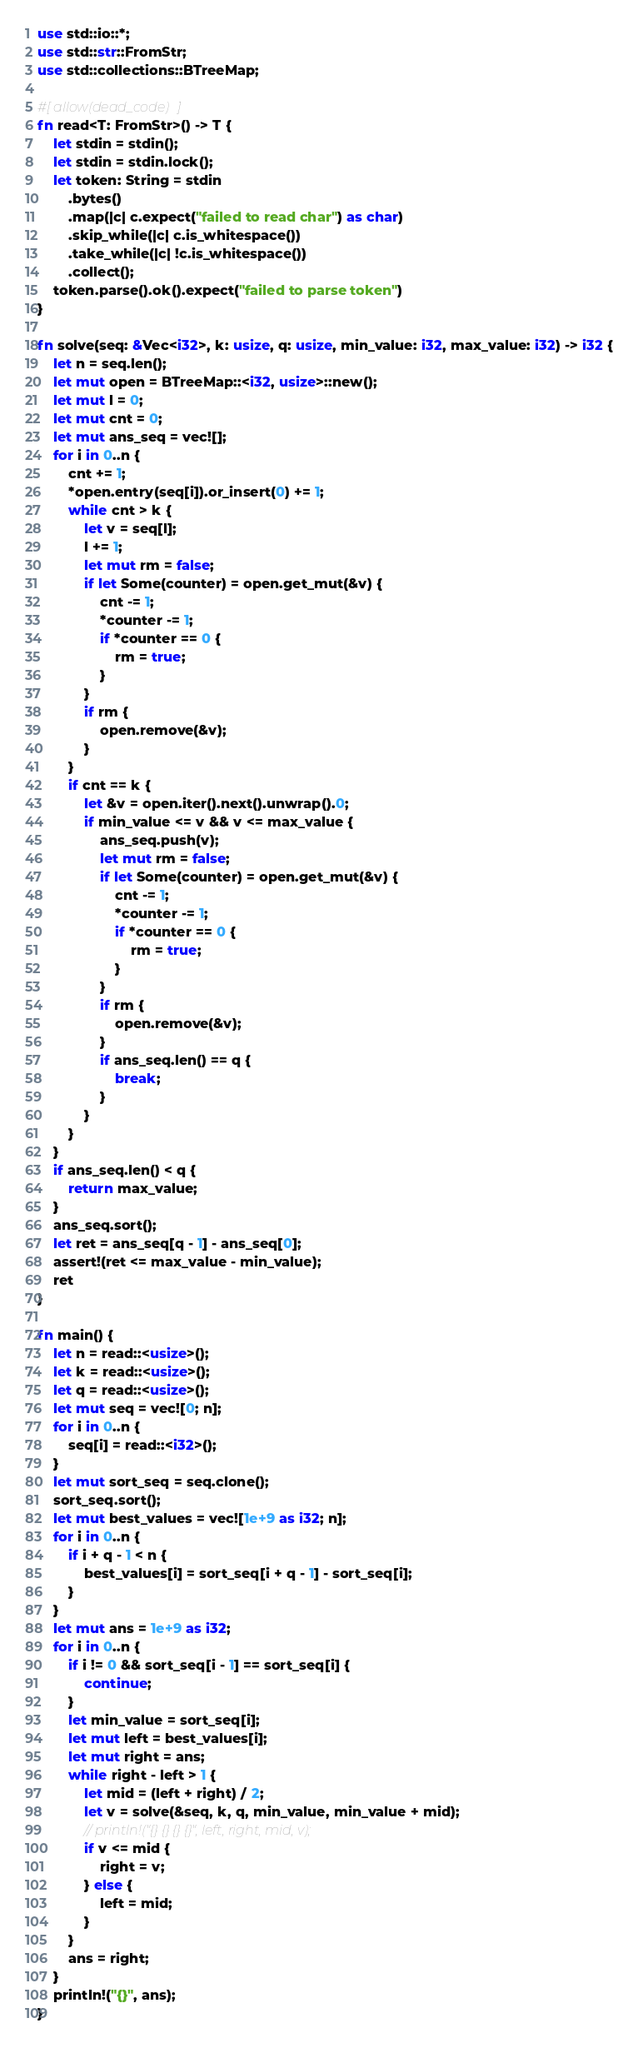<code> <loc_0><loc_0><loc_500><loc_500><_Rust_>use std::io::*;
use std::str::FromStr;
use std::collections::BTreeMap;

#[allow(dead_code)]
fn read<T: FromStr>() -> T {
    let stdin = stdin();
    let stdin = stdin.lock();
    let token: String = stdin
        .bytes()
        .map(|c| c.expect("failed to read char") as char)
        .skip_while(|c| c.is_whitespace())
        .take_while(|c| !c.is_whitespace())
        .collect();
    token.parse().ok().expect("failed to parse token")
}

fn solve(seq: &Vec<i32>, k: usize, q: usize, min_value: i32, max_value: i32) -> i32 {
    let n = seq.len();
    let mut open = BTreeMap::<i32, usize>::new();
    let mut l = 0;
    let mut cnt = 0;
    let mut ans_seq = vec![];
    for i in 0..n {
        cnt += 1;
        *open.entry(seq[i]).or_insert(0) += 1;
        while cnt > k {
            let v = seq[l];
            l += 1;
            let mut rm = false;
            if let Some(counter) = open.get_mut(&v) {
                cnt -= 1;
                *counter -= 1;
                if *counter == 0 {
                    rm = true;
                }
            }
            if rm {
                open.remove(&v);
            }
        }
        if cnt == k {
            let &v = open.iter().next().unwrap().0;
            if min_value <= v && v <= max_value {
                ans_seq.push(v);
                let mut rm = false;
                if let Some(counter) = open.get_mut(&v) {
                    cnt -= 1;
                    *counter -= 1;
                    if *counter == 0 {
                        rm = true;
                    }
                }
                if rm {
                    open.remove(&v);
                }
                if ans_seq.len() == q {
                    break;
                }
            }
        }
    }
    if ans_seq.len() < q {
        return max_value;
    }
    ans_seq.sort();
    let ret = ans_seq[q - 1] - ans_seq[0];
    assert!(ret <= max_value - min_value);
    ret
}

fn main() {
    let n = read::<usize>();
    let k = read::<usize>();
    let q = read::<usize>();
    let mut seq = vec![0; n];
    for i in 0..n {
        seq[i] = read::<i32>();
    }
    let mut sort_seq = seq.clone();
    sort_seq.sort();
    let mut best_values = vec![1e+9 as i32; n];
    for i in 0..n {
        if i + q - 1 < n {
            best_values[i] = sort_seq[i + q - 1] - sort_seq[i];
        }
    }
    let mut ans = 1e+9 as i32;
    for i in 0..n {
        if i != 0 && sort_seq[i - 1] == sort_seq[i] {
            continue;
        }
        let min_value = sort_seq[i];
        let mut left = best_values[i];
        let mut right = ans;
        while right - left > 1 {
            let mid = (left + right) / 2;
            let v = solve(&seq, k, q, min_value, min_value + mid);
            // println!("{} {} {} {}", left, right, mid, v);
            if v <= mid {
                right = v;
            } else {
                left = mid;
            }
        }
        ans = right;
    }
    println!("{}", ans);
}
</code> 